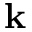<formula> <loc_0><loc_0><loc_500><loc_500>k</formula> 